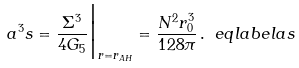<formula> <loc_0><loc_0><loc_500><loc_500>a ^ { 3 } s = \frac { \Sigma ^ { 3 } } { 4 G _ { 5 } } \Big | _ { r = r _ { A H } } = \frac { N ^ { 2 } r _ { 0 } ^ { 3 } } { 1 2 8 \pi } \, . \ e q l a b e l { a s }</formula> 